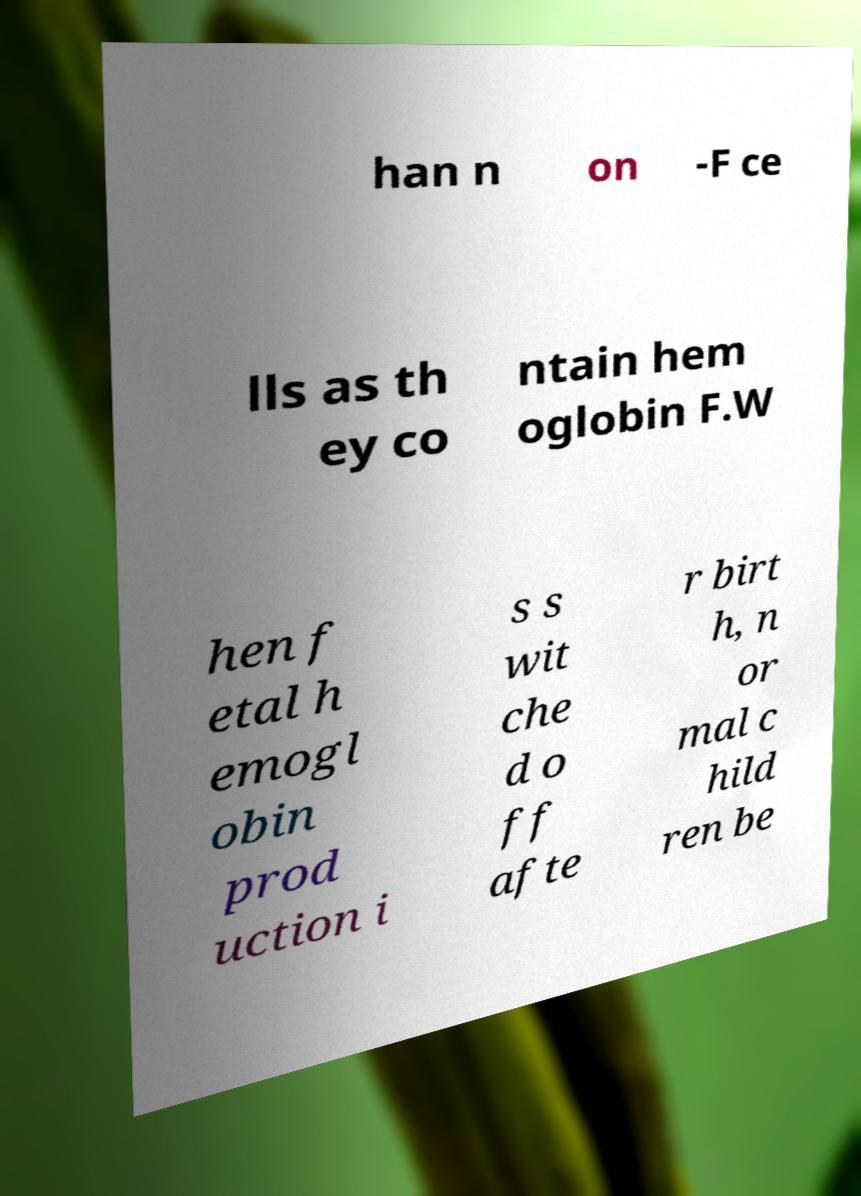What messages or text are displayed in this image? I need them in a readable, typed format. han n on -F ce lls as th ey co ntain hem oglobin F.W hen f etal h emogl obin prod uction i s s wit che d o ff afte r birt h, n or mal c hild ren be 